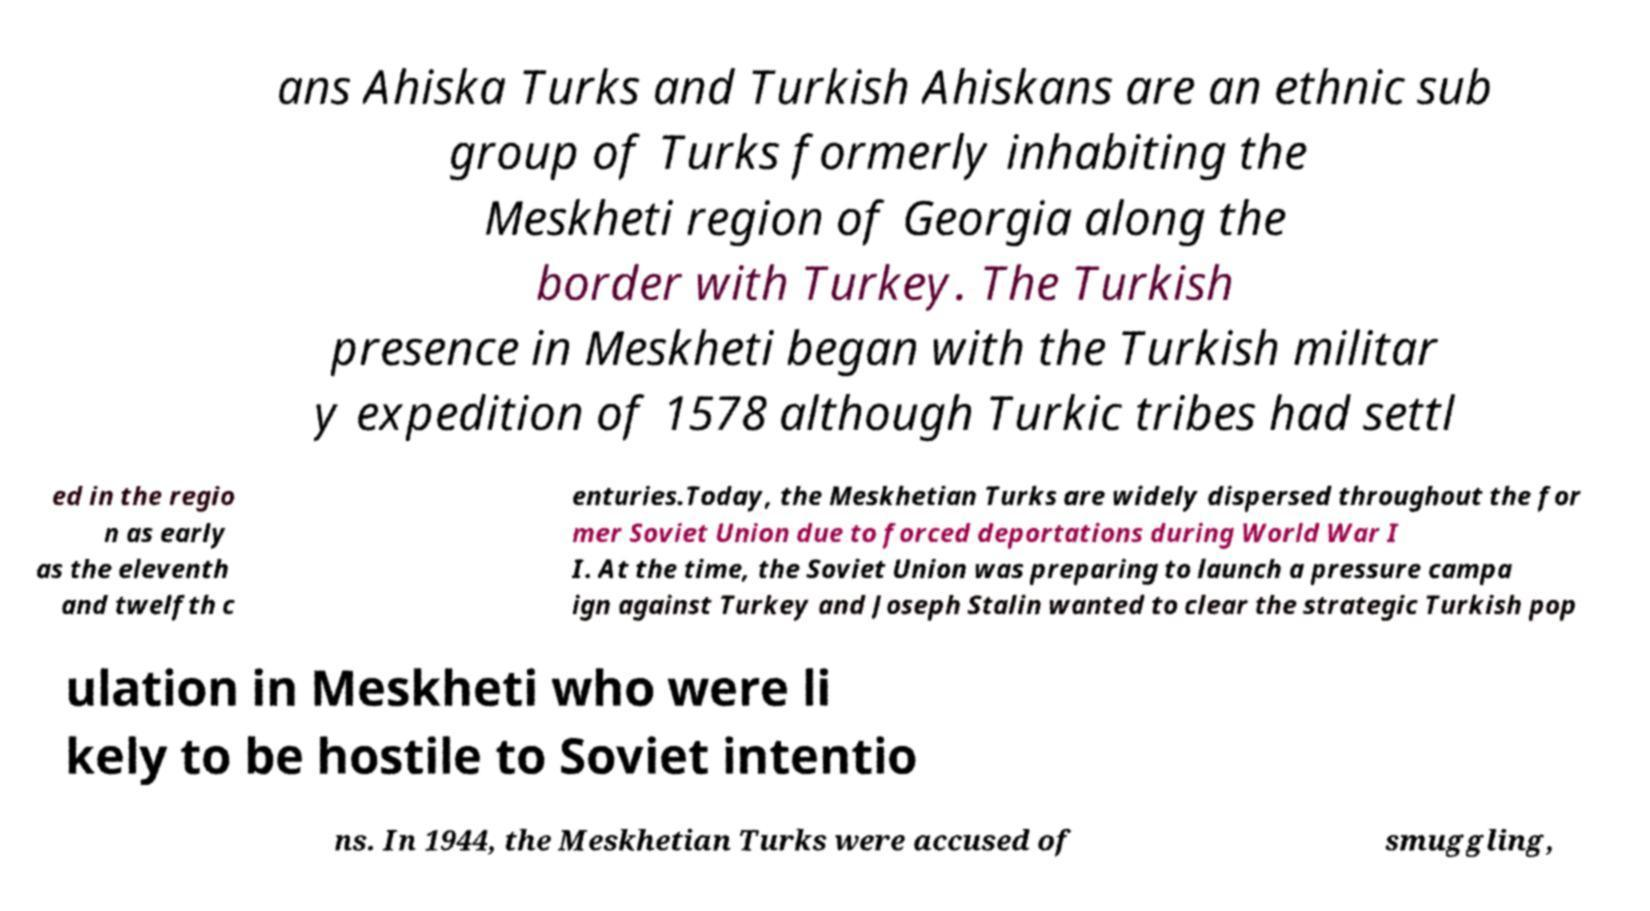Please read and relay the text visible in this image. What does it say? ans Ahiska Turks and Turkish Ahiskans are an ethnic sub group of Turks formerly inhabiting the Meskheti region of Georgia along the border with Turkey. The Turkish presence in Meskheti began with the Turkish militar y expedition of 1578 although Turkic tribes had settl ed in the regio n as early as the eleventh and twelfth c enturies.Today, the Meskhetian Turks are widely dispersed throughout the for mer Soviet Union due to forced deportations during World War I I. At the time, the Soviet Union was preparing to launch a pressure campa ign against Turkey and Joseph Stalin wanted to clear the strategic Turkish pop ulation in Meskheti who were li kely to be hostile to Soviet intentio ns. In 1944, the Meskhetian Turks were accused of smuggling, 